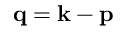Convert formula to latex. <formula><loc_0><loc_0><loc_500><loc_500>{ q = k - p }</formula> 